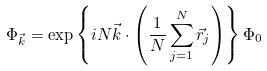<formula> <loc_0><loc_0><loc_500><loc_500>\Phi _ { \vec { k } } = \exp { \left \{ i N \vec { k } \cdot \left ( \frac { 1 } { N } \sum _ { j = 1 } ^ { N } \vec { r } _ { j } \right ) \right \} } \, \Phi _ { 0 }</formula> 